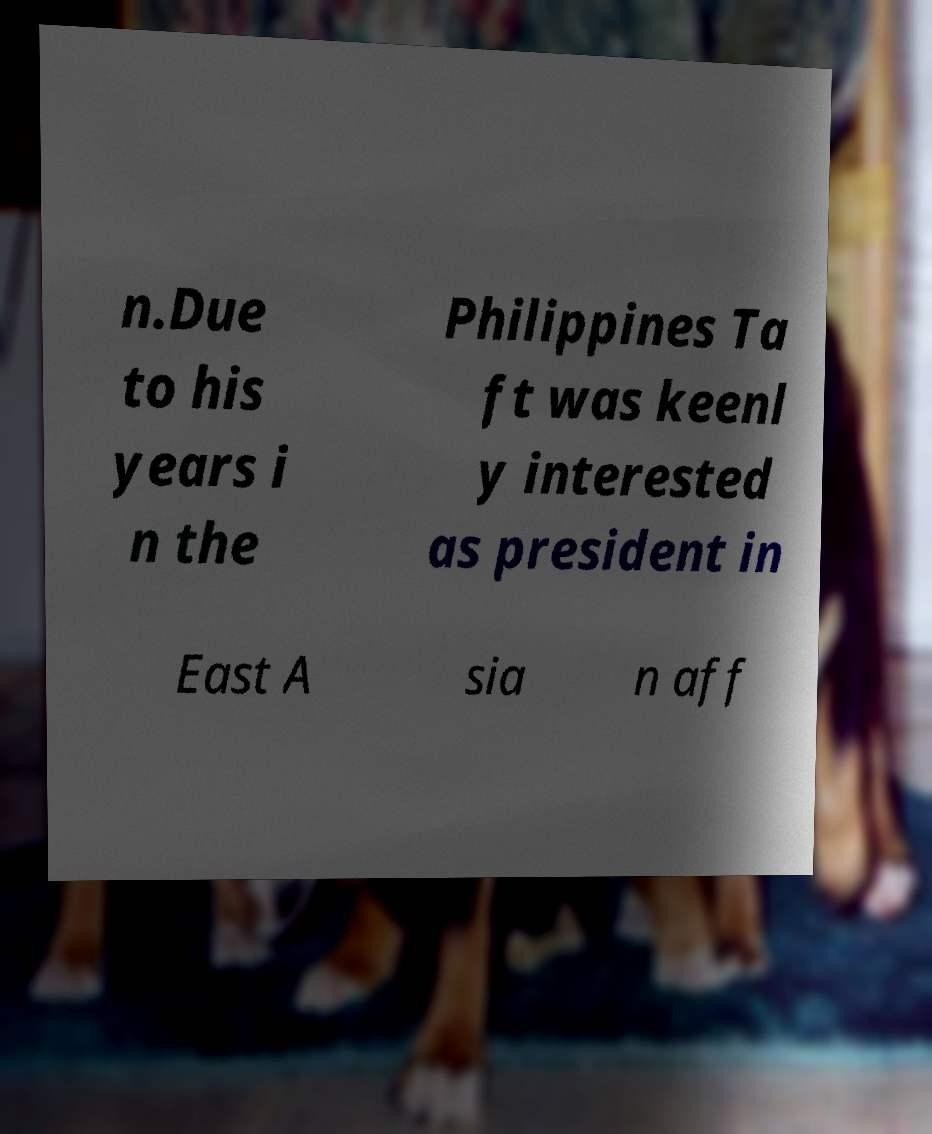I need the written content from this picture converted into text. Can you do that? n.Due to his years i n the Philippines Ta ft was keenl y interested as president in East A sia n aff 